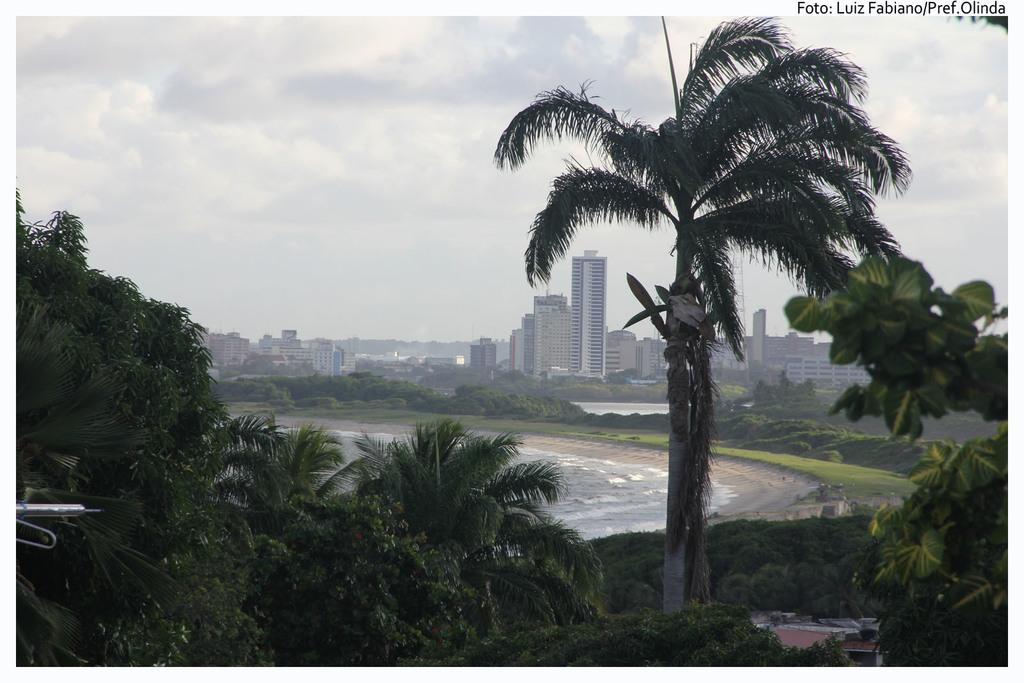What is the primary feature of the image? There is a water surface in the image. What can be seen surrounding the water surface? There are many trees and plants around the water surface. What can be seen in the distance in the image? There are buildings visible in the background of the image. What note is being played by the tree in the image? There are no musical instruments or notes present in the image; it features a water surface surrounded by trees and plants, with buildings visible in the background. 